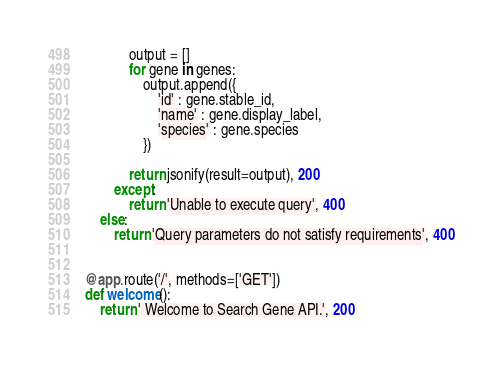Convert code to text. <code><loc_0><loc_0><loc_500><loc_500><_Python_>            output = []
            for gene in genes:
                output.append({
                    'id' : gene.stable_id,
                    'name' : gene.display_label,
                    'species' : gene.species
                })

            return jsonify(result=output), 200
        except:
            return 'Unable to execute query', 400
    else:
        return 'Query parameters do not satisfy requirements', 400


@app.route('/', methods=['GET'])
def welcome():
    return ' Welcome to Search Gene API.', 200
</code> 